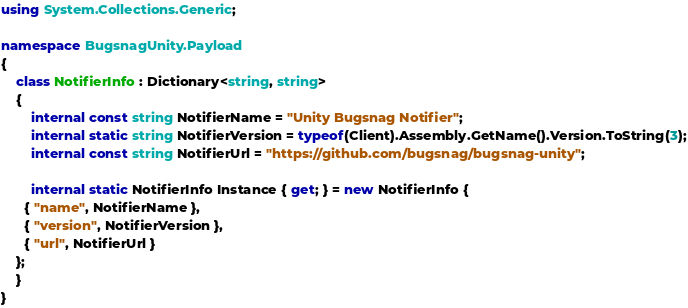Convert code to text. <code><loc_0><loc_0><loc_500><loc_500><_C#_>using System.Collections.Generic;

namespace BugsnagUnity.Payload
{
    class NotifierInfo : Dictionary<string, string>
    {
        internal const string NotifierName = "Unity Bugsnag Notifier";
        internal static string NotifierVersion = typeof(Client).Assembly.GetName().Version.ToString(3);
        internal const string NotifierUrl = "https://github.com/bugsnag/bugsnag-unity";

        internal static NotifierInfo Instance { get; } = new NotifierInfo {
      { "name", NotifierName },
      { "version", NotifierVersion },
      { "url", NotifierUrl }
    };
    }
}
</code> 